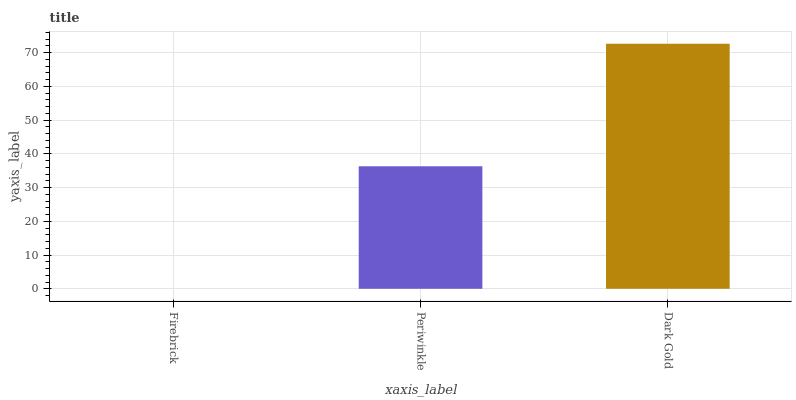Is Firebrick the minimum?
Answer yes or no. Yes. Is Dark Gold the maximum?
Answer yes or no. Yes. Is Periwinkle the minimum?
Answer yes or no. No. Is Periwinkle the maximum?
Answer yes or no. No. Is Periwinkle greater than Firebrick?
Answer yes or no. Yes. Is Firebrick less than Periwinkle?
Answer yes or no. Yes. Is Firebrick greater than Periwinkle?
Answer yes or no. No. Is Periwinkle less than Firebrick?
Answer yes or no. No. Is Periwinkle the high median?
Answer yes or no. Yes. Is Periwinkle the low median?
Answer yes or no. Yes. Is Firebrick the high median?
Answer yes or no. No. Is Dark Gold the low median?
Answer yes or no. No. 